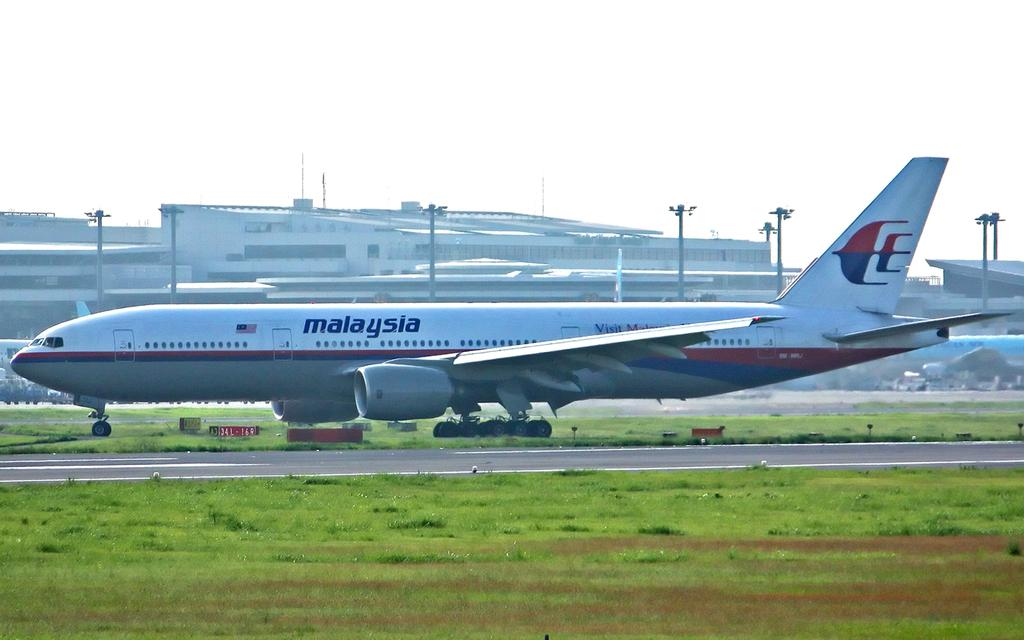<image>
Create a compact narrative representing the image presented. A white Malaysia Airlines airplane on a runway. 